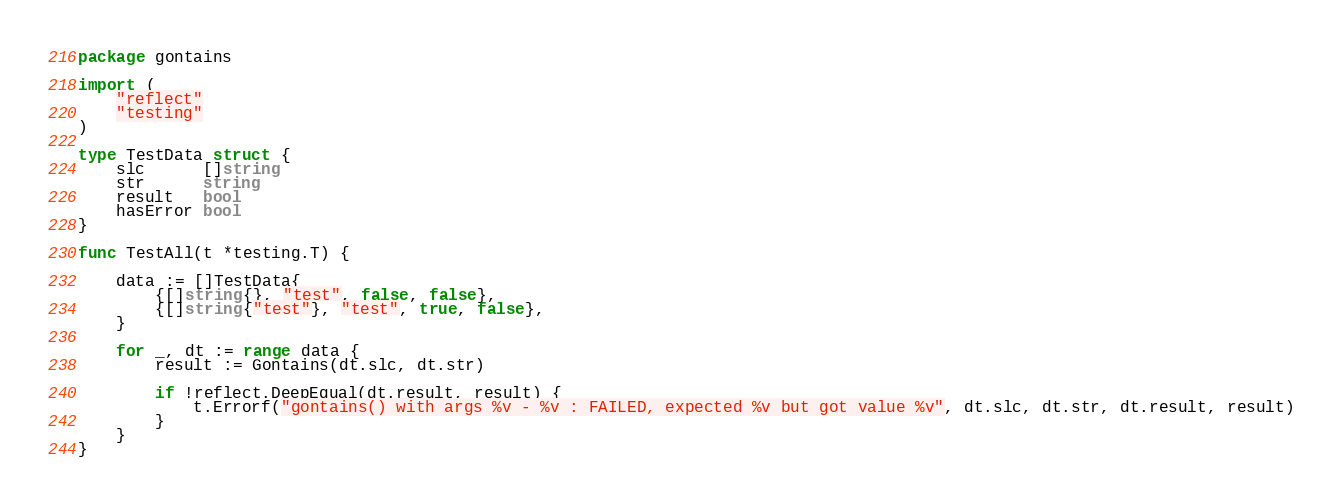Convert code to text. <code><loc_0><loc_0><loc_500><loc_500><_Go_>package gontains

import (
	"reflect"
	"testing"
)

type TestData struct {
	slc      []string
	str      string
	result   bool
	hasError bool
}

func TestAll(t *testing.T) {

	data := []TestData{
		{[]string{}, "test", false, false},
		{[]string{"test"}, "test", true, false},
	}

	for _, dt := range data {
		result := Gontains(dt.slc, dt.str)

		if !reflect.DeepEqual(dt.result, result) {
			t.Errorf("gontains() with args %v - %v : FAILED, expected %v but got value %v", dt.slc, dt.str, dt.result, result)
		}
	}
}
</code> 